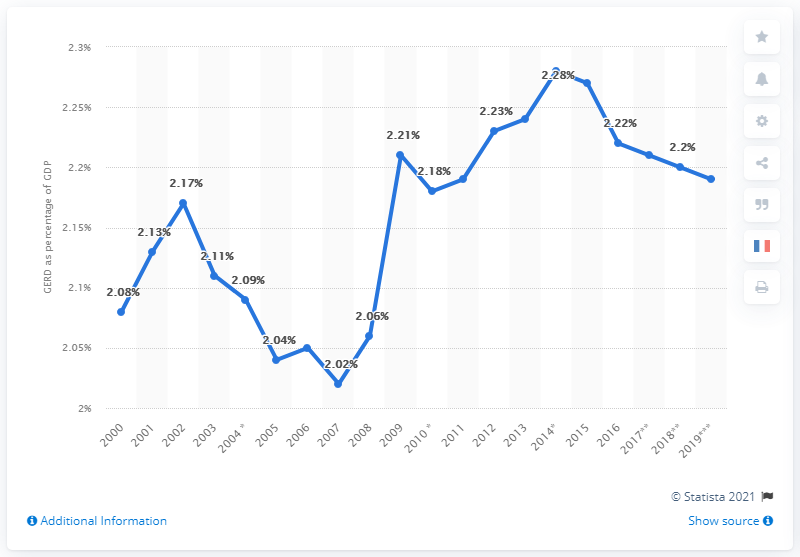Specify some key components in this picture. In 2007, the Global Energy Review Database (GERD) recorded the lowest energy consumption on record. The year with a significant increase and the percentage change have been identified as [2009, 0.15]. In 2014, GEPD constituted approximately 2.28% of the total GDP of France. 